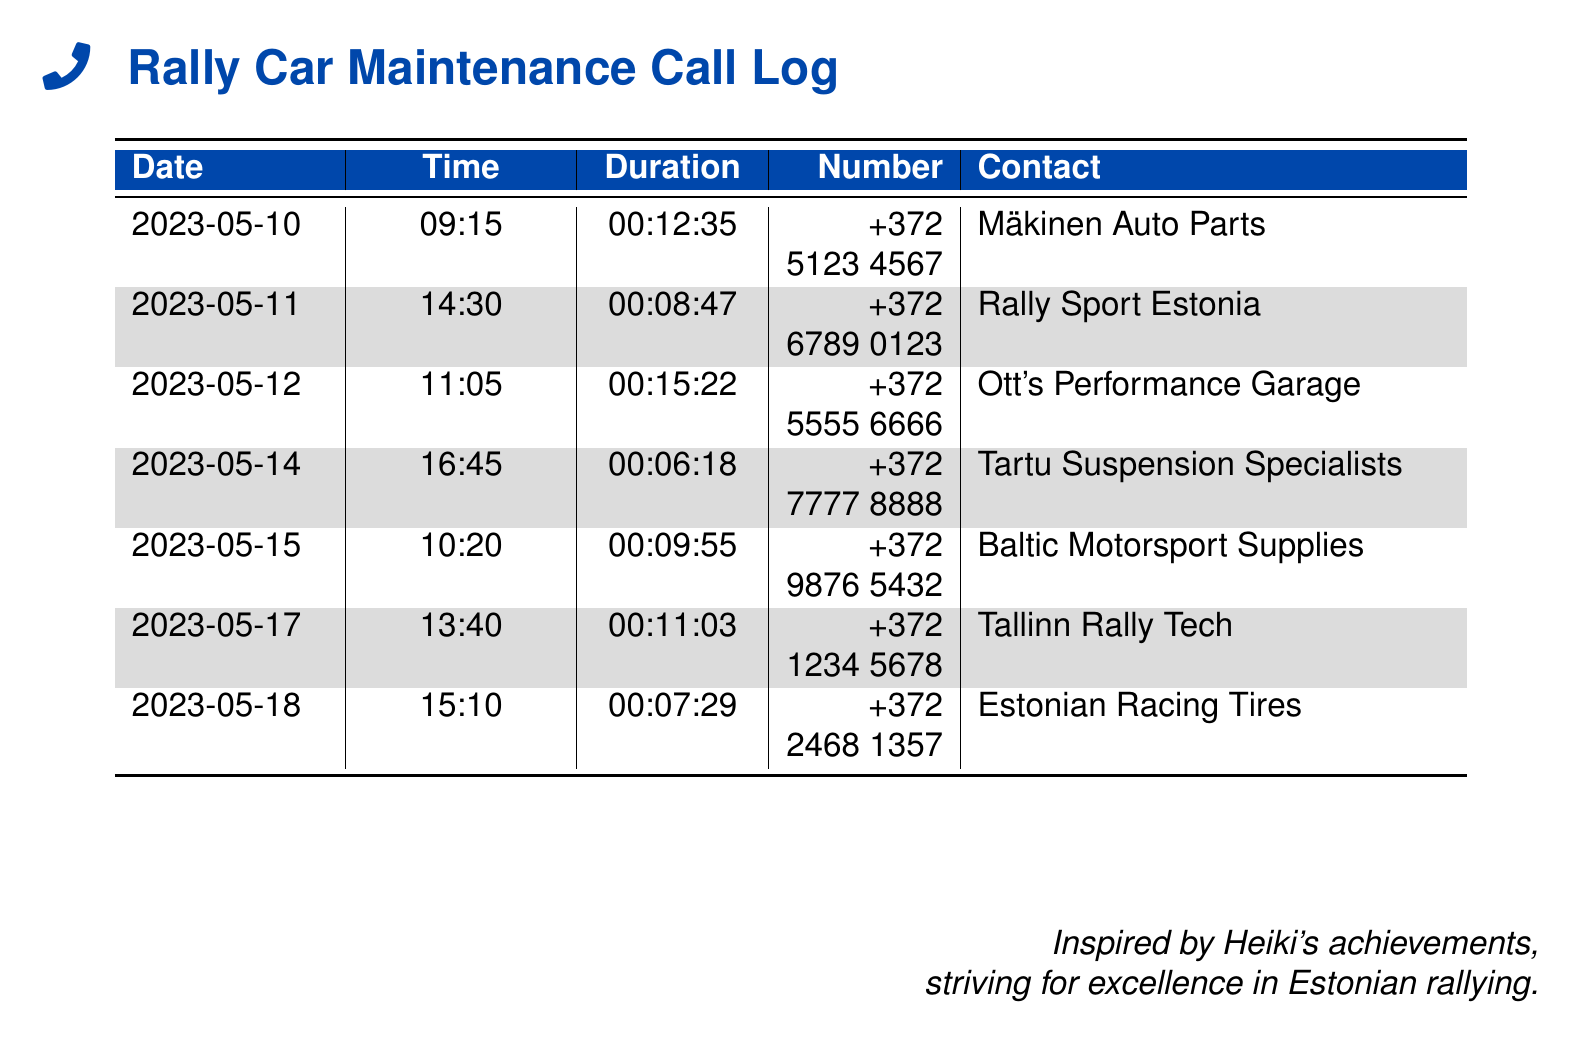what is the date of the first recorded call? The first recorded call is on 2023-05-10.
Answer: 2023-05-10 who did the second call go to? The second call was made to Rally Sport Estonia.
Answer: Rally Sport Estonia how long was the call to Ott's Performance Garage? The call duration to Ott's Performance Garage is mentioned in the document as 00:15:22.
Answer: 00:15:22 what type of services do the contacts provide? The contacts provide services related to rally car maintenance and upgrades, as suggested by their names.
Answer: rally car maintenance and upgrades how many calls were made in total? The document lists a total of 6 calls.
Answer: 6 which number corresponds to the Tartu Suspension Specialists? The contact number for Tartu Suspension Specialists is +372 7777 8888.
Answer: +372 7777 8888 what is the time of the last recorded call? The last recorded call was made at 15:10.
Answer: 15:10 which contact was called on May 17? On May 17, the call was made to Tallinn Rally Tech.
Answer: Tallinn Rally Tech 